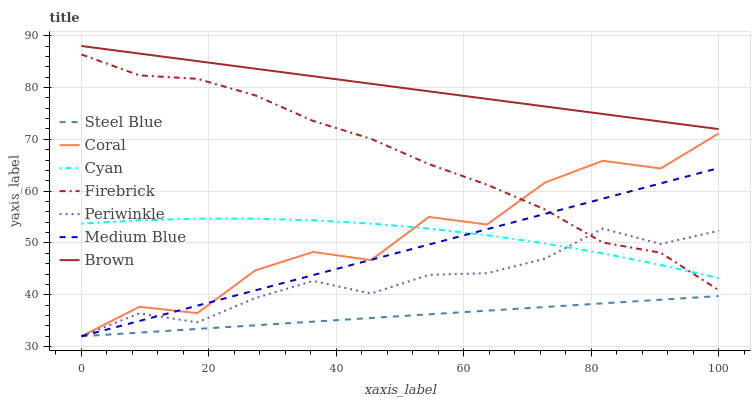Does Steel Blue have the minimum area under the curve?
Answer yes or no. Yes. Does Brown have the maximum area under the curve?
Answer yes or no. Yes. Does Coral have the minimum area under the curve?
Answer yes or no. No. Does Coral have the maximum area under the curve?
Answer yes or no. No. Is Steel Blue the smoothest?
Answer yes or no. Yes. Is Coral the roughest?
Answer yes or no. Yes. Is Medium Blue the smoothest?
Answer yes or no. No. Is Medium Blue the roughest?
Answer yes or no. No. Does Coral have the lowest value?
Answer yes or no. Yes. Does Cyan have the lowest value?
Answer yes or no. No. Does Brown have the highest value?
Answer yes or no. Yes. Does Coral have the highest value?
Answer yes or no. No. Is Steel Blue less than Cyan?
Answer yes or no. Yes. Is Brown greater than Steel Blue?
Answer yes or no. Yes. Does Firebrick intersect Periwinkle?
Answer yes or no. Yes. Is Firebrick less than Periwinkle?
Answer yes or no. No. Is Firebrick greater than Periwinkle?
Answer yes or no. No. Does Steel Blue intersect Cyan?
Answer yes or no. No. 